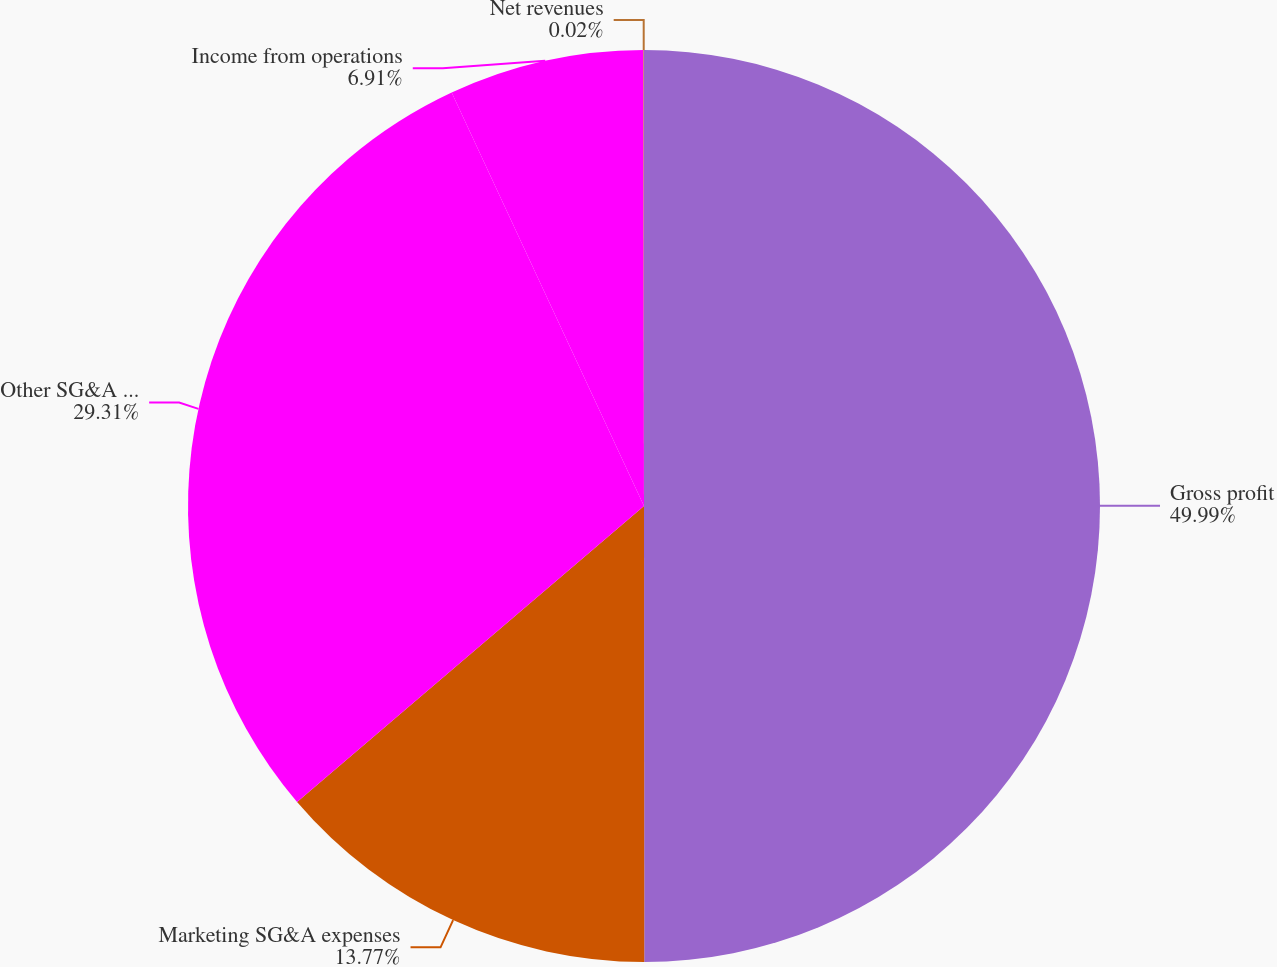<chart> <loc_0><loc_0><loc_500><loc_500><pie_chart><fcel>Gross profit<fcel>Marketing SG&A expenses<fcel>Other SG&A expenses<fcel>Income from operations<fcel>Net revenues<nl><fcel>49.99%<fcel>13.77%<fcel>29.31%<fcel>6.91%<fcel>0.02%<nl></chart> 